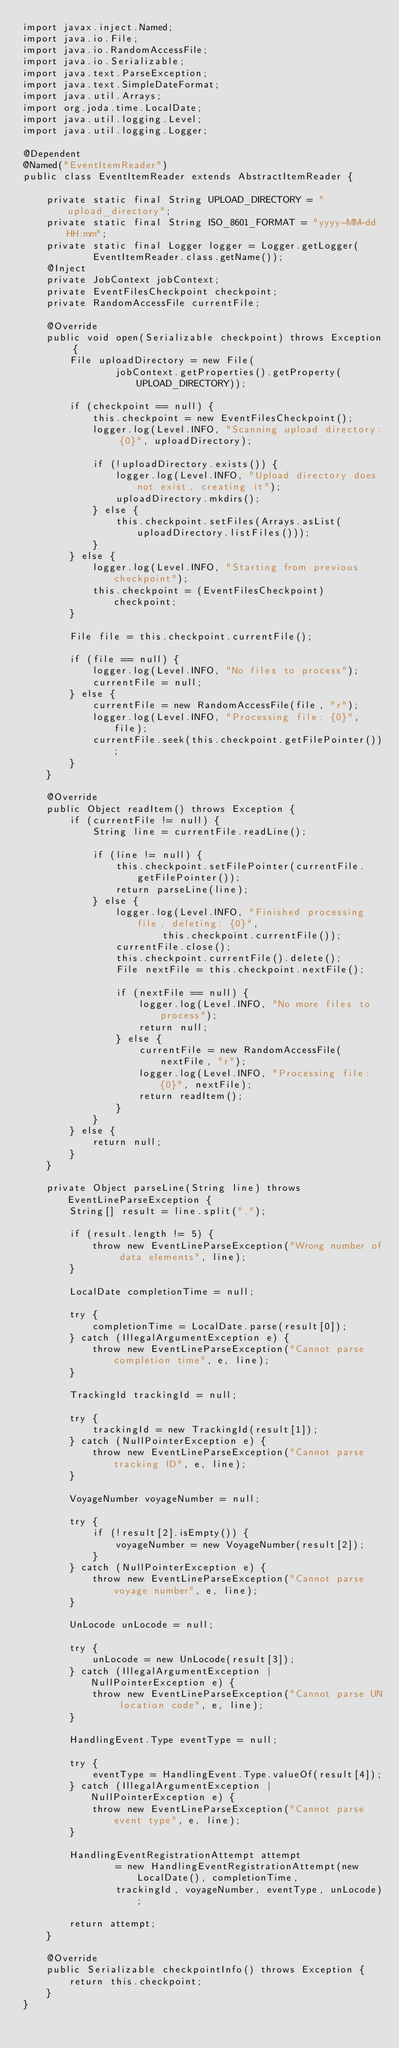Convert code to text. <code><loc_0><loc_0><loc_500><loc_500><_Java_>import javax.inject.Named;
import java.io.File;
import java.io.RandomAccessFile;
import java.io.Serializable;
import java.text.ParseException;
import java.text.SimpleDateFormat;
import java.util.Arrays;
import org.joda.time.LocalDate;
import java.util.logging.Level;
import java.util.logging.Logger;

@Dependent
@Named("EventItemReader")
public class EventItemReader extends AbstractItemReader {

    private static final String UPLOAD_DIRECTORY = "upload_directory";
    private static final String ISO_8601_FORMAT = "yyyy-MM-dd HH:mm";
    private static final Logger logger = Logger.getLogger(
            EventItemReader.class.getName());
    @Inject
    private JobContext jobContext;
    private EventFilesCheckpoint checkpoint;
    private RandomAccessFile currentFile;

    @Override
    public void open(Serializable checkpoint) throws Exception {
        File uploadDirectory = new File(
                jobContext.getProperties().getProperty(UPLOAD_DIRECTORY));

        if (checkpoint == null) {
            this.checkpoint = new EventFilesCheckpoint();
            logger.log(Level.INFO, "Scanning upload directory: {0}", uploadDirectory);

            if (!uploadDirectory.exists()) {
                logger.log(Level.INFO, "Upload directory does not exist, creating it");
                uploadDirectory.mkdirs();
            } else {
                this.checkpoint.setFiles(Arrays.asList(uploadDirectory.listFiles()));
            }
        } else {
            logger.log(Level.INFO, "Starting from previous checkpoint");
            this.checkpoint = (EventFilesCheckpoint) checkpoint;
        }

        File file = this.checkpoint.currentFile();

        if (file == null) {
            logger.log(Level.INFO, "No files to process");
            currentFile = null;
        } else {
            currentFile = new RandomAccessFile(file, "r");
            logger.log(Level.INFO, "Processing file: {0}", file);
            currentFile.seek(this.checkpoint.getFilePointer());
        }
    }

    @Override
    public Object readItem() throws Exception {
        if (currentFile != null) {
            String line = currentFile.readLine();

            if (line != null) {
                this.checkpoint.setFilePointer(currentFile.getFilePointer());
                return parseLine(line);
            } else {
                logger.log(Level.INFO, "Finished processing file, deleting: {0}",
                        this.checkpoint.currentFile());
                currentFile.close();
                this.checkpoint.currentFile().delete();
                File nextFile = this.checkpoint.nextFile();

                if (nextFile == null) {
                    logger.log(Level.INFO, "No more files to process");
                    return null;
                } else {
                    currentFile = new RandomAccessFile(nextFile, "r");
                    logger.log(Level.INFO, "Processing file: {0}", nextFile);
                    return readItem();
                }
            }
        } else {
            return null;
        }
    }

    private Object parseLine(String line) throws EventLineParseException {
        String[] result = line.split(",");

        if (result.length != 5) {
            throw new EventLineParseException("Wrong number of data elements", line);
        }

        LocalDate completionTime = null;

        try {
            completionTime = LocalDate.parse(result[0]);
        } catch (IllegalArgumentException e) {
            throw new EventLineParseException("Cannot parse completion time", e, line);
        }

        TrackingId trackingId = null;

        try {
            trackingId = new TrackingId(result[1]);
        } catch (NullPointerException e) {
            throw new EventLineParseException("Cannot parse tracking ID", e, line);
        }

        VoyageNumber voyageNumber = null;

        try {
            if (!result[2].isEmpty()) {
                voyageNumber = new VoyageNumber(result[2]);
            }
        } catch (NullPointerException e) {
            throw new EventLineParseException("Cannot parse voyage number", e, line);
        }

        UnLocode unLocode = null;

        try {
            unLocode = new UnLocode(result[3]);
        } catch (IllegalArgumentException | NullPointerException e) {
            throw new EventLineParseException("Cannot parse UN location code", e, line);
        }

        HandlingEvent.Type eventType = null;

        try {
            eventType = HandlingEvent.Type.valueOf(result[4]);
        } catch (IllegalArgumentException | NullPointerException e) {
            throw new EventLineParseException("Cannot parse event type", e, line);
        }

        HandlingEventRegistrationAttempt attempt
                = new HandlingEventRegistrationAttempt(new LocalDate(), completionTime,
                trackingId, voyageNumber, eventType, unLocode);

        return attempt;
    }

    @Override
    public Serializable checkpointInfo() throws Exception {
        return this.checkpoint;
    }
}
</code> 